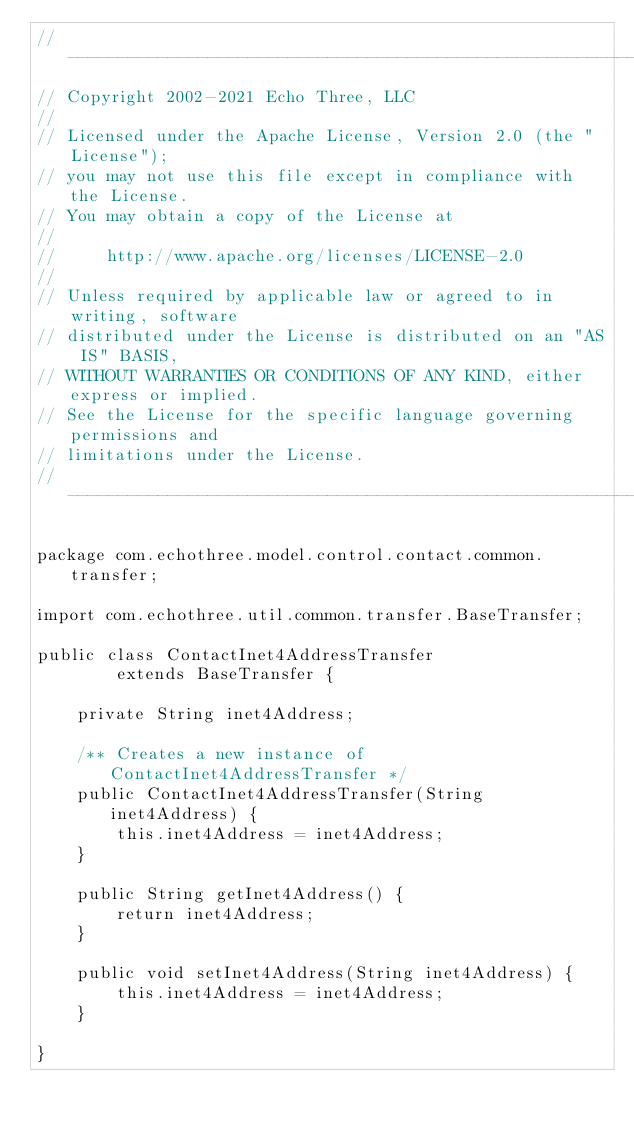<code> <loc_0><loc_0><loc_500><loc_500><_Java_>// --------------------------------------------------------------------------------
// Copyright 2002-2021 Echo Three, LLC
//
// Licensed under the Apache License, Version 2.0 (the "License");
// you may not use this file except in compliance with the License.
// You may obtain a copy of the License at
//
//     http://www.apache.org/licenses/LICENSE-2.0
//
// Unless required by applicable law or agreed to in writing, software
// distributed under the License is distributed on an "AS IS" BASIS,
// WITHOUT WARRANTIES OR CONDITIONS OF ANY KIND, either express or implied.
// See the License for the specific language governing permissions and
// limitations under the License.
// --------------------------------------------------------------------------------

package com.echothree.model.control.contact.common.transfer;

import com.echothree.util.common.transfer.BaseTransfer;

public class ContactInet4AddressTransfer
        extends BaseTransfer {
    
    private String inet4Address;
    
    /** Creates a new instance of ContactInet4AddressTransfer */
    public ContactInet4AddressTransfer(String inet4Address) {
        this.inet4Address = inet4Address;
    }
    
    public String getInet4Address() {
        return inet4Address;
    }
    
    public void setInet4Address(String inet4Address) {
        this.inet4Address = inet4Address;
    }
    
}
</code> 